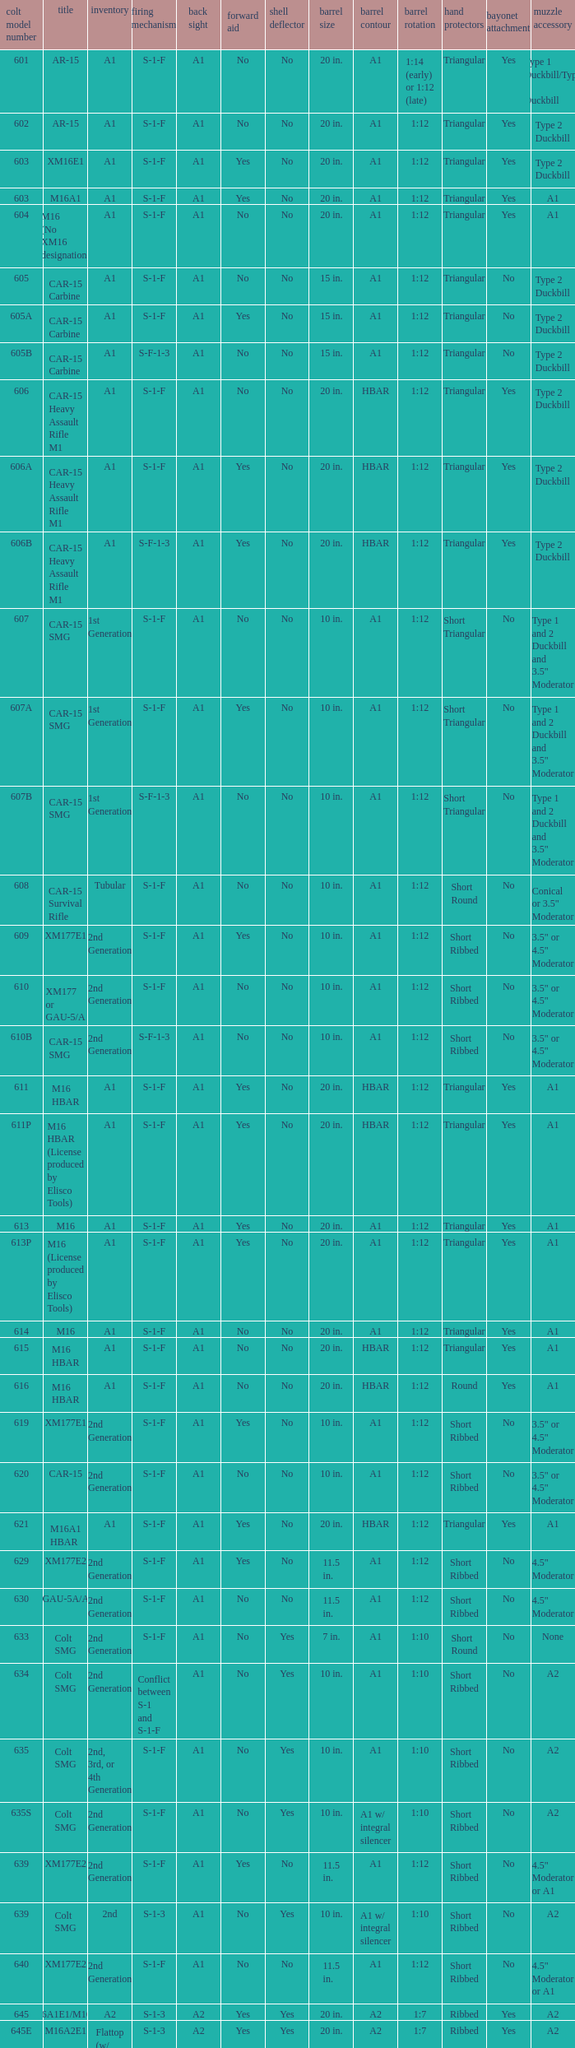What's the type of muzzle devices on the models with round hand guards? A1. Parse the table in full. {'header': ['colt model number', 'title', 'inventory', 'firing mechanism', 'back sight', 'forward aid', 'shell deflector', 'barrel size', 'barrel contour', 'barrel rotation', 'hand protectors', 'bayonet attachment', 'muzzle accessory'], 'rows': [['601', 'AR-15', 'A1', 'S-1-F', 'A1', 'No', 'No', '20 in.', 'A1', '1:14 (early) or 1:12 (late)', 'Triangular', 'Yes', 'Type 1 Duckbill/Type 2 Duckbill'], ['602', 'AR-15', 'A1', 'S-1-F', 'A1', 'No', 'No', '20 in.', 'A1', '1:12', 'Triangular', 'Yes', 'Type 2 Duckbill'], ['603', 'XM16E1', 'A1', 'S-1-F', 'A1', 'Yes', 'No', '20 in.', 'A1', '1:12', 'Triangular', 'Yes', 'Type 2 Duckbill'], ['603', 'M16A1', 'A1', 'S-1-F', 'A1', 'Yes', 'No', '20 in.', 'A1', '1:12', 'Triangular', 'Yes', 'A1'], ['604', 'M16 (No XM16 designation)', 'A1', 'S-1-F', 'A1', 'No', 'No', '20 in.', 'A1', '1:12', 'Triangular', 'Yes', 'A1'], ['605', 'CAR-15 Carbine', 'A1', 'S-1-F', 'A1', 'No', 'No', '15 in.', 'A1', '1:12', 'Triangular', 'No', 'Type 2 Duckbill'], ['605A', 'CAR-15 Carbine', 'A1', 'S-1-F', 'A1', 'Yes', 'No', '15 in.', 'A1', '1:12', 'Triangular', 'No', 'Type 2 Duckbill'], ['605B', 'CAR-15 Carbine', 'A1', 'S-F-1-3', 'A1', 'No', 'No', '15 in.', 'A1', '1:12', 'Triangular', 'No', 'Type 2 Duckbill'], ['606', 'CAR-15 Heavy Assault Rifle M1', 'A1', 'S-1-F', 'A1', 'No', 'No', '20 in.', 'HBAR', '1:12', 'Triangular', 'Yes', 'Type 2 Duckbill'], ['606A', 'CAR-15 Heavy Assault Rifle M1', 'A1', 'S-1-F', 'A1', 'Yes', 'No', '20 in.', 'HBAR', '1:12', 'Triangular', 'Yes', 'Type 2 Duckbill'], ['606B', 'CAR-15 Heavy Assault Rifle M1', 'A1', 'S-F-1-3', 'A1', 'Yes', 'No', '20 in.', 'HBAR', '1:12', 'Triangular', 'Yes', 'Type 2 Duckbill'], ['607', 'CAR-15 SMG', '1st Generation', 'S-1-F', 'A1', 'No', 'No', '10 in.', 'A1', '1:12', 'Short Triangular', 'No', 'Type 1 and 2 Duckbill and 3.5" Moderator'], ['607A', 'CAR-15 SMG', '1st Generation', 'S-1-F', 'A1', 'Yes', 'No', '10 in.', 'A1', '1:12', 'Short Triangular', 'No', 'Type 1 and 2 Duckbill and 3.5" Moderator'], ['607B', 'CAR-15 SMG', '1st Generation', 'S-F-1-3', 'A1', 'No', 'No', '10 in.', 'A1', '1:12', 'Short Triangular', 'No', 'Type 1 and 2 Duckbill and 3.5" Moderator'], ['608', 'CAR-15 Survival Rifle', 'Tubular', 'S-1-F', 'A1', 'No', 'No', '10 in.', 'A1', '1:12', 'Short Round', 'No', 'Conical or 3.5" Moderator'], ['609', 'XM177E1', '2nd Generation', 'S-1-F', 'A1', 'Yes', 'No', '10 in.', 'A1', '1:12', 'Short Ribbed', 'No', '3.5" or 4.5" Moderator'], ['610', 'XM177 or GAU-5/A', '2nd Generation', 'S-1-F', 'A1', 'No', 'No', '10 in.', 'A1', '1:12', 'Short Ribbed', 'No', '3.5" or 4.5" Moderator'], ['610B', 'CAR-15 SMG', '2nd Generation', 'S-F-1-3', 'A1', 'No', 'No', '10 in.', 'A1', '1:12', 'Short Ribbed', 'No', '3.5" or 4.5" Moderator'], ['611', 'M16 HBAR', 'A1', 'S-1-F', 'A1', 'Yes', 'No', '20 in.', 'HBAR', '1:12', 'Triangular', 'Yes', 'A1'], ['611P', 'M16 HBAR (License produced by Elisco Tools)', 'A1', 'S-1-F', 'A1', 'Yes', 'No', '20 in.', 'HBAR', '1:12', 'Triangular', 'Yes', 'A1'], ['613', 'M16', 'A1', 'S-1-F', 'A1', 'Yes', 'No', '20 in.', 'A1', '1:12', 'Triangular', 'Yes', 'A1'], ['613P', 'M16 (License produced by Elisco Tools)', 'A1', 'S-1-F', 'A1', 'Yes', 'No', '20 in.', 'A1', '1:12', 'Triangular', 'Yes', 'A1'], ['614', 'M16', 'A1', 'S-1-F', 'A1', 'No', 'No', '20 in.', 'A1', '1:12', 'Triangular', 'Yes', 'A1'], ['615', 'M16 HBAR', 'A1', 'S-1-F', 'A1', 'No', 'No', '20 in.', 'HBAR', '1:12', 'Triangular', 'Yes', 'A1'], ['616', 'M16 HBAR', 'A1', 'S-1-F', 'A1', 'No', 'No', '20 in.', 'HBAR', '1:12', 'Round', 'Yes', 'A1'], ['619', 'XM177E1', '2nd Generation', 'S-1-F', 'A1', 'Yes', 'No', '10 in.', 'A1', '1:12', 'Short Ribbed', 'No', '3.5" or 4.5" Moderator'], ['620', 'CAR-15', '2nd Generation', 'S-1-F', 'A1', 'No', 'No', '10 in.', 'A1', '1:12', 'Short Ribbed', 'No', '3.5" or 4.5" Moderator'], ['621', 'M16A1 HBAR', 'A1', 'S-1-F', 'A1', 'Yes', 'No', '20 in.', 'HBAR', '1:12', 'Triangular', 'Yes', 'A1'], ['629', 'XM177E2', '2nd Generation', 'S-1-F', 'A1', 'Yes', 'No', '11.5 in.', 'A1', '1:12', 'Short Ribbed', 'No', '4.5" Moderator'], ['630', 'GAU-5A/A', '2nd Generation', 'S-1-F', 'A1', 'No', 'No', '11.5 in.', 'A1', '1:12', 'Short Ribbed', 'No', '4.5" Moderator'], ['633', 'Colt SMG', '2nd Generation', 'S-1-F', 'A1', 'No', 'Yes', '7 in.', 'A1', '1:10', 'Short Round', 'No', 'None'], ['634', 'Colt SMG', '2nd Generation', 'Conflict between S-1 and S-1-F', 'A1', 'No', 'Yes', '10 in.', 'A1', '1:10', 'Short Ribbed', 'No', 'A2'], ['635', 'Colt SMG', '2nd, 3rd, or 4th Generation', 'S-1-F', 'A1', 'No', 'Yes', '10 in.', 'A1', '1:10', 'Short Ribbed', 'No', 'A2'], ['635S', 'Colt SMG', '2nd Generation', 'S-1-F', 'A1', 'No', 'Yes', '10 in.', 'A1 w/ integral silencer', '1:10', 'Short Ribbed', 'No', 'A2'], ['639', 'XM177E2', '2nd Generation', 'S-1-F', 'A1', 'Yes', 'No', '11.5 in.', 'A1', '1:12', 'Short Ribbed', 'No', '4.5" Moderator or A1'], ['639', 'Colt SMG', '2nd', 'S-1-3', 'A1', 'No', 'Yes', '10 in.', 'A1 w/ integral silencer', '1:10', 'Short Ribbed', 'No', 'A2'], ['640', 'XM177E2', '2nd Generation', 'S-1-F', 'A1', 'No', 'No', '11.5 in.', 'A1', '1:12', 'Short Ribbed', 'No', '4.5" Moderator or A1'], ['645', 'M16A1E1/M16A2', 'A2', 'S-1-3', 'A2', 'Yes', 'Yes', '20 in.', 'A2', '1:7', 'Ribbed', 'Yes', 'A2'], ['645E', 'M16A2E1', 'Flattop (w/ flip down front sight)', 'S-1-3', 'A2', 'Yes', 'Yes', '20 in.', 'A2', '1:7', 'Ribbed', 'Yes', 'A2'], ['646', 'M16A2E3/M16A3', 'A2', 'S-1-F', 'A2', 'Yes', 'Yes', '20 in.', 'A2', '1:7', 'Ribbed', 'Yes', 'A2'], ['649', 'GAU-5A/A', '2nd Generation', 'S-1-F', 'A1', 'No', 'No', '11.5 in.', 'A1', '1:12', 'Short Ribbed', 'No', '4.5" Moderator'], ['650', 'M16A1 carbine', 'A1', 'S-1-F', 'A1', 'Yes', 'No', '14.5 in.', 'A1', '1:12', 'Short Ribbed', 'Yes', 'A1'], ['651', 'M16A1 carbine', 'A1', 'S-1-F', 'A1', 'Yes', 'No', '14.5 in.', 'A1', '1:12', 'Short Ribbed', 'Yes', 'A1'], ['652', 'M16A1 carbine', 'A1', 'S-1-F', 'A1', 'No', 'No', '14.5 in.', 'A1', '1:12', 'Short Ribbed', 'Yes', 'A1'], ['653', 'M16A1 carbine', '2nd Generation', 'S-1-F', 'A1', 'Yes', 'No', '14.5 in.', 'A1', '1:12', 'Short Ribbed', 'Yes', 'A1'], ['653P', 'M16A1 carbine (License produced by Elisco Tools)', '2nd Generation', 'S-1-F', 'A1', 'Yes', 'No', '14.5 in.', 'A1', '1:12', 'Short Ribbed', 'Yes', 'A1'], ['654', 'M16A1 carbine', '2nd Generation', 'S-1-F', 'A1', 'No', 'No', '14.5 in.', 'A1', '1:12', 'Short Ribbed', 'Yes', 'A1'], ['656', 'M16A1 Special Low Profile', 'A1', 'S-1-F', 'Flattop', 'Yes', 'No', '20 in.', 'HBAR', '1:12', 'Triangular', 'Yes', 'A1'], ['701', 'M16A2', 'A2', 'S-1-F', 'A2', 'Yes', 'Yes', '20 in.', 'A2', '1:7', 'Ribbed', 'Yes', 'A2'], ['702', 'M16A2', 'A2', 'S-1-3', 'A2', 'Yes', 'Yes', '20 in.', 'A2', '1:7', 'Ribbed', 'Yes', 'A2'], ['703', 'M16A2', 'A2', 'S-1-F', 'A2', 'Yes', 'Yes', '20 in.', 'A1', '1:7', 'Ribbed', 'Yes', 'A2'], ['705', 'M16A2', 'A2', 'S-1-3', 'A2', 'Yes', 'Yes', '20 in.', 'A2', '1:7', 'Ribbed', 'Yes', 'A2'], ['707', 'M16A2', 'A2', 'S-1-3', 'A2', 'Yes', 'Yes', '20 in.', 'A1', '1:7', 'Ribbed', 'Yes', 'A2'], ['711', 'M16A2', 'A2', 'S-1-F', 'A1', 'Yes', 'No and Yes', '20 in.', 'A1', '1:7', 'Ribbed', 'Yes', 'A2'], ['713', 'M16A2', 'A2', 'S-1-3', 'A2', 'Yes', 'Yes', '20 in.', 'A2', '1:7', 'Ribbed', 'Yes', 'A2'], ['719', 'M16A2', 'A2', 'S-1-3', 'A2', 'Yes', 'Yes', '20 in.', 'A1', '1:7', 'Ribbed', 'Yes', 'A2'], ['720', 'XM4 Carbine', '3rd Generation', 'S-1-3', 'A2', 'Yes', 'Yes', '14.5 in.', 'M4', '1:7', 'Short Ribbed', 'Yes', 'A2'], ['723', 'M16A2 carbine', '3rd Generation', 'S-1-F', 'A1', 'Yes', 'Yes', '14.5 in.', 'A1', '1:7', 'Short Ribbed', 'Yes', 'A1'], ['725A', 'M16A2 carbine', '3rd Generation', 'S-1-F', 'A1', 'Yes', 'Yes', '14.5 in.', 'A1', '1:7', 'Short Ribbed', 'Yes', 'A2'], ['725B', 'M16A2 carbine', '3rd Generation', 'S-1-F', 'A1', 'Yes', 'Yes', '14.5 in.', 'A2', '1:7', 'Short Ribbed', 'Yes', 'A2'], ['726', 'M16A2 carbine', '3rd Generation', 'S-1-F', 'A1', 'Yes', 'Yes', '14.5 in.', 'A1', '1:7', 'Short Ribbed', 'Yes', 'A1'], ['727', 'M16A2 carbine', '3rd Generation', 'S-1-F', 'A2', 'Yes', 'Yes', '14.5 in.', 'M4', '1:7', 'Short Ribbed', 'Yes', 'A2'], ['728', 'M16A2 carbine', '3rd Generation', 'S-1-F', 'A2', 'Yes', 'Yes', '14.5 in.', 'M4', '1:7', 'Short Ribbed', 'Yes', 'A2'], ['733', 'M16A2 Commando / M4 Commando', '3rd or 4th Generation', 'S-1-F', 'A1 or A2', 'Yes', 'Yes or No', '11.5 in.', 'A1 or A2', '1:7', 'Short Ribbed', 'No', 'A1 or A2'], ['733A', 'M16A2 Commando / M4 Commando', '3rd or 4th Generation', 'S-1-3', 'A1 or A2', 'Yes', 'Yes or No', '11.5 in.', 'A1 or A2', '1:7', 'Short Ribbed', 'No', 'A1 or A2'], ['734', 'M16A2 Commando', '3rd Generation', 'S-1-F', 'A1 or A2', 'Yes', 'Yes or No', '11.5 in.', 'A1 or A2', '1:7', 'Short Ribbed', 'No', 'A1 or A2'], ['734A', 'M16A2 Commando', '3rd Generation', 'S-1-3', 'A1 or A2', 'Yes', 'Yes or No', '11.5 in.', 'A1 or A2', '1:7', 'Short Ribbed', 'No', 'A1 or A2'], ['735', 'M16A2 Commando / M4 Commando', '3rd or 4th Generation', 'S-1-3', 'A1 or A2', 'Yes', 'Yes or No', '11.5 in.', 'A1 or A2', '1:7', 'Short Ribbed', 'No', 'A1 or A2'], ['737', 'M16A2', 'A2', 'S-1-3', 'A2', 'Yes', 'Yes', '20 in.', 'HBAR', '1:7', 'Ribbed', 'Yes', 'A2'], ['738', 'M4 Commando Enhanced', '4th Generation', 'S-1-3-F', 'A2', 'Yes', 'Yes', '11.5 in.', 'A2', '1:7', 'Short Ribbed', 'No', 'A1 or A2'], ['741', 'M16A2', 'A2', 'S-1-F', 'A2', 'Yes', 'Yes', '20 in.', 'HBAR', '1:7', 'Ribbed', 'Yes', 'A2'], ['742', 'M16A2 (Standard w/ bipod)', 'A2', 'S-1-F', 'A2', 'Yes', 'Yes', '20 in.', 'HBAR', '1:7', 'Ribbed', 'Yes', 'A2'], ['745', 'M16A2 (Standard w/ bipod)', 'A2', 'S-1-3', 'A2', 'Yes', 'Yes', '20 in.', 'HBAR', '1:7', 'Ribbed', 'Yes', 'A2'], ['746', 'M16A2 (Standard w/ bipod)', 'A2', 'S-1-3', 'A2', 'Yes', 'Yes', '20 in.', 'HBAR', '1:7', 'Ribbed', 'Yes', 'A2'], ['750', 'LMG (Colt/ Diemaco project)', 'A2', 'S-F', 'A2', 'Yes', 'Yes', '20 in.', 'HBAR', '1:7', 'Square LMG', 'Yes', 'A2'], ['777', 'M4 Carbine', '4th Generation', 'S-1-3', 'A2', 'Yes', 'Yes', '14.5 in.', 'M4', '1:7', 'M4', 'Yes', 'A2'], ['778', 'M4 Carbine Enhanced', '4th Generation', 'S-1-3-F', 'A2', 'Yes', 'Yes', '14.5 in.', 'M4', '1:7', 'M4', 'Yes', 'A2'], ['779', 'M4 Carbine', '4th Generation', 'S-1-F', 'A2', 'Yes', 'Yes', '14.5 in.', 'M4', '1:7', 'M4', 'Yes', 'A2'], ['901', 'M16A3', 'A2', 'S-1-F', 'Flattop', 'Yes', 'Yes', '20 in.', 'A2', '1:7', 'Ribbed', 'Yes', 'A2'], ['905', 'M16A4', 'A2', 'S-1-3', 'Flattop', 'Yes', 'Yes', '20 in.', 'A2', '1:7', 'Ribbed', 'Yes', 'A2'], ['920', 'M4 Carbine', '3rd and 4th Generation', 'S-1-3', 'Flattop', 'Yes', 'Yes', '14.5 in.', 'M4', '1:7', 'M4', 'Yes', 'A2'], ['921', 'M4E1/A1 Carbine', '4th Generation', 'S-1-F', 'Flattop', 'Yes', 'Yes', '14.5 in.', 'M4', '1:7', 'M4', 'Yes', 'A2'], ['921HB', 'M4A1 Carbine', '4th Generation', 'S-1-F', 'Flattop', 'Yes', 'Yes', '14.5 in.', 'M4 HBAR', '1:7', 'M4', 'Yes', 'A2'], ['925', 'M4E2 Carbine', '3rd or 4th Generation', 'S-1-3', 'Flattop', 'Yes', 'Yes', '14.5 in.', 'M4', '1:7', 'M4', 'Yes', 'A2'], ['927', 'M4 Carbine', '4th Generation', 'S-1-F', 'Flattop', 'Yes', 'Yes', '14.5 in.', 'M4', '1:7', 'M4', 'Yes', 'A2'], ['933', 'M4 Commando', '4th Generation', 'S-1-F', 'Flattop', 'Yes', 'Yes', '11.5 in.', 'A1 or A2', '1:7', 'Short Ribbed', 'No', 'A2'], ['935', 'M4 Commando', '4th Generation', 'S-1-3', 'Flattop', 'Yes', 'Yes', '11.5 in.', 'A1 or A2', '1:7', 'Short Ribbed', 'No', 'A2'], ['938', 'M4 Commando Enhanced', '4th Generation', 'S-1-3-F', 'Flattop', 'Yes', 'Yes', '11.5 in.', 'A2', '1:7', 'M4', 'No', 'A2'], ['977', 'M4 Carbine', '4th Generation', 'S-1-3', 'Flattop', 'Yes', 'Yes', '14.5 in.', 'M4', '1:7', 'M4', 'Yes', 'A2'], ['941', 'M16A3', 'A2', 'S-1-F', 'Flattop', 'Yes', 'Yes', '20 in.', 'HBAR', '1:7', 'Ribbed', 'Yes', 'A2'], ['942', 'M16A3 (Standard w/ bipod)', 'A2', 'S-1-F', 'Flattop', 'Yes', 'Yes', '20 in.', 'HBAR', '1:7', 'Ribbed', 'Yes', 'A2'], ['945', 'M16A2E4/M16A4', 'A2', 'S-1-3', 'Flattop', 'Yes', 'Yes', '20 in.', 'A2', '1:7', 'Ribbed', 'Yes', 'A2'], ['950', 'LMG (Colt/ Diemaco project)', 'A2', 'S-F', 'Flattop', 'Yes', 'Yes', '20 in.', 'HBAR', '1:7', 'Square LMG', 'Yes', 'A2'], ['"977"', 'M4 Carbine', '4th Generation', 'S-1-3', 'Flattop', 'Yes', 'Yes', '14.5 in.', 'M4', '1:7', 'M4', 'Yes', 'A2'], ['978', 'M4 Carbine Enhanced', '4th Generation', 'S-1-3-F', 'Flattop', 'Yes', 'Yes', '14.5 in.', 'M4', '1:7', 'M4', 'Yes', 'A2'], ['979', 'M4A1 Carbine', '4th Generation', 'S-1-F', 'Flattop', 'Yes', 'Yes', '14.5 in.', 'M4', '1:7', 'M4', 'Yes', 'A2']]} 